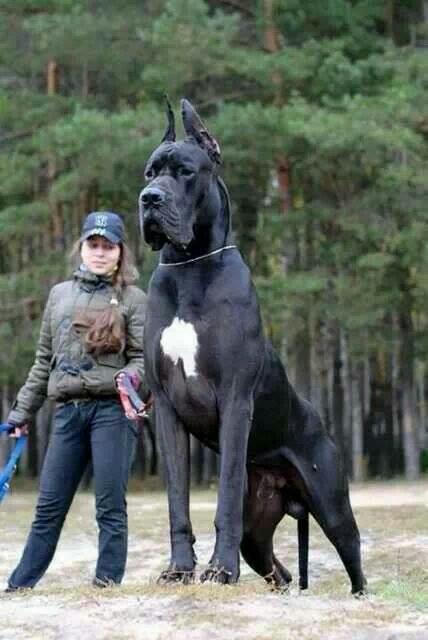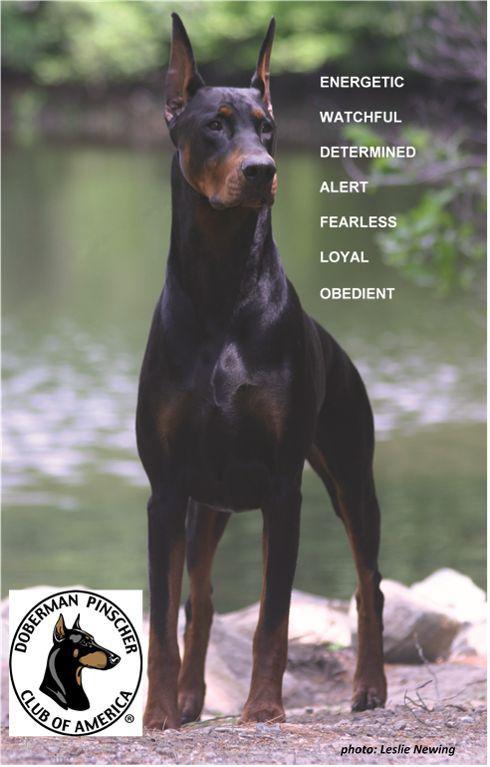The first image is the image on the left, the second image is the image on the right. Analyze the images presented: Is the assertion "The left image shows a black and brown dog with its mouth open and teeth visible." valid? Answer yes or no. No. The first image is the image on the left, the second image is the image on the right. Considering the images on both sides, is "The left image features a doberman in a collar with its head in profile facing right, and the right image features a dock-tailed doberman standing on all fours with body angled leftward." valid? Answer yes or no. No. 